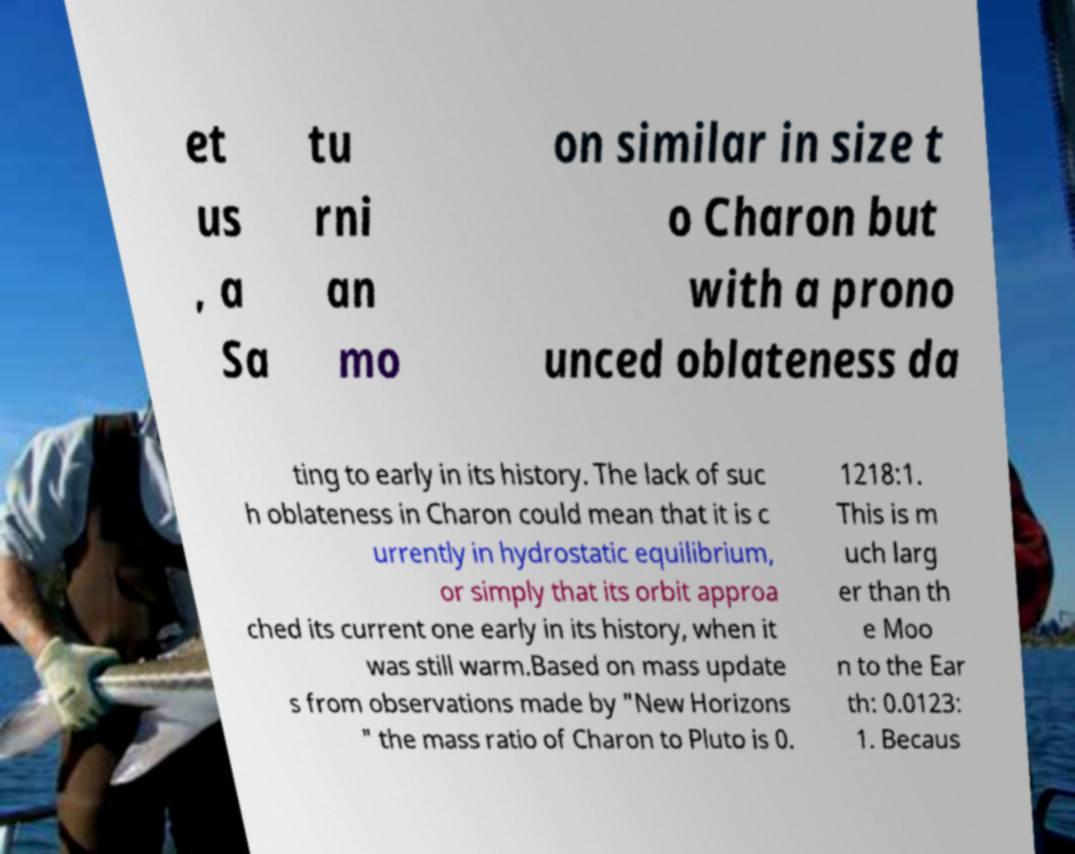Can you read and provide the text displayed in the image?This photo seems to have some interesting text. Can you extract and type it out for me? et us , a Sa tu rni an mo on similar in size t o Charon but with a prono unced oblateness da ting to early in its history. The lack of suc h oblateness in Charon could mean that it is c urrently in hydrostatic equilibrium, or simply that its orbit approa ched its current one early in its history, when it was still warm.Based on mass update s from observations made by "New Horizons " the mass ratio of Charon to Pluto is 0. 1218:1. This is m uch larg er than th e Moo n to the Ear th: 0.0123: 1. Becaus 